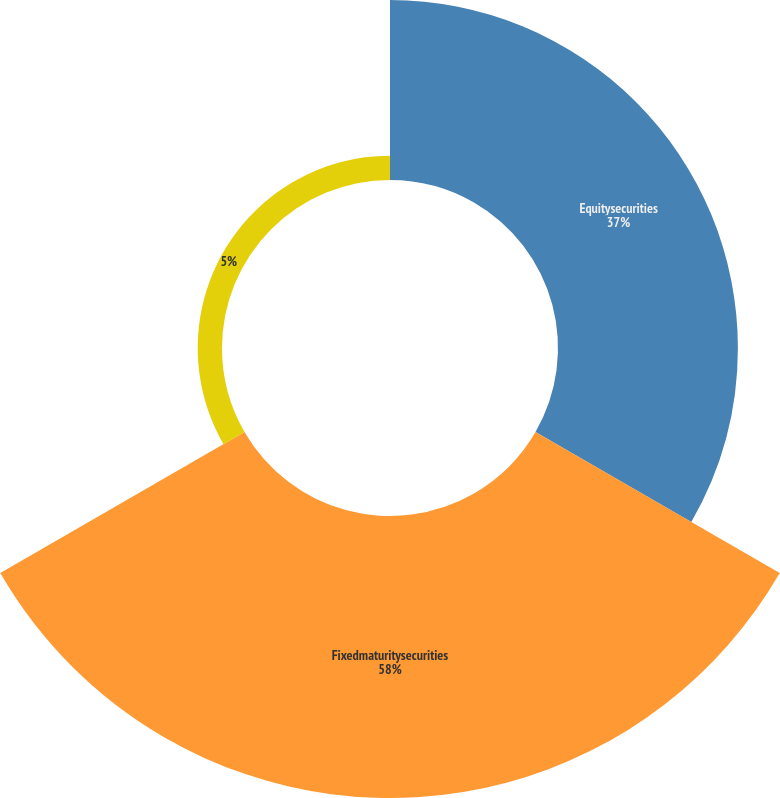Convert chart to OTSL. <chart><loc_0><loc_0><loc_500><loc_500><pie_chart><fcel>Equitysecurities<fcel>Fixedmaturitysecurities<fcel>Unnamed: 2<nl><fcel>37.0%<fcel>58.0%<fcel>5.0%<nl></chart> 